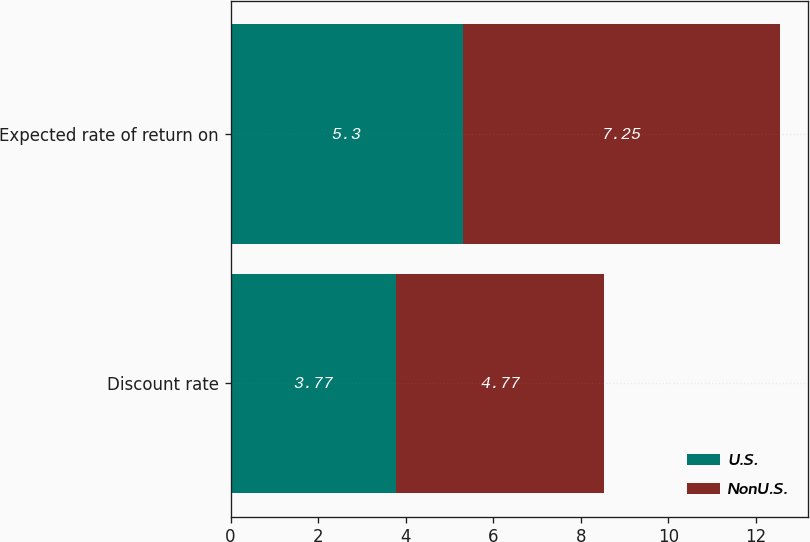<chart> <loc_0><loc_0><loc_500><loc_500><stacked_bar_chart><ecel><fcel>Discount rate<fcel>Expected rate of return on<nl><fcel>U.S.<fcel>3.77<fcel>5.3<nl><fcel>NonU.S.<fcel>4.77<fcel>7.25<nl></chart> 